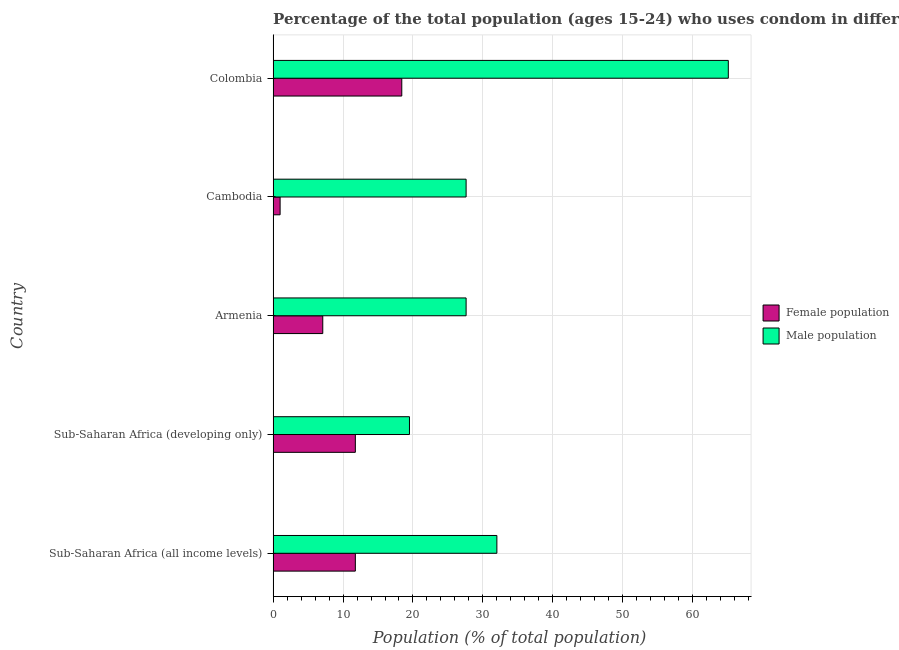How many bars are there on the 2nd tick from the bottom?
Your answer should be compact. 2. What is the label of the 5th group of bars from the top?
Ensure brevity in your answer.  Sub-Saharan Africa (all income levels). In how many cases, is the number of bars for a given country not equal to the number of legend labels?
Give a very brief answer. 0. What is the female population in Armenia?
Provide a succinct answer. 7.1. Across all countries, what is the maximum male population?
Your answer should be compact. 65.1. Across all countries, what is the minimum female population?
Provide a succinct answer. 1. In which country was the male population maximum?
Your answer should be very brief. Colombia. In which country was the male population minimum?
Your response must be concise. Sub-Saharan Africa (developing only). What is the total male population in the graph?
Offer a terse response. 171.8. What is the difference between the female population in Cambodia and that in Sub-Saharan Africa (all income levels)?
Offer a very short reply. -10.76. What is the difference between the female population in Colombia and the male population in Sub-Saharan Africa (developing only)?
Give a very brief answer. -1.1. What is the average male population per country?
Offer a terse response. 34.36. What is the difference between the female population and male population in Sub-Saharan Africa (all income levels)?
Make the answer very short. -20.24. What is the ratio of the female population in Armenia to that in Sub-Saharan Africa (developing only)?
Your answer should be compact. 0.6. Is the male population in Cambodia less than that in Colombia?
Provide a succinct answer. Yes. What is the difference between the highest and the second highest female population?
Give a very brief answer. 6.64. Is the sum of the male population in Cambodia and Sub-Saharan Africa (all income levels) greater than the maximum female population across all countries?
Provide a short and direct response. Yes. What does the 2nd bar from the top in Colombia represents?
Your answer should be compact. Female population. What does the 1st bar from the bottom in Colombia represents?
Give a very brief answer. Female population. Are all the bars in the graph horizontal?
Provide a succinct answer. Yes. How many countries are there in the graph?
Your answer should be compact. 5. Are the values on the major ticks of X-axis written in scientific E-notation?
Your response must be concise. No. Does the graph contain grids?
Provide a succinct answer. Yes. What is the title of the graph?
Make the answer very short. Percentage of the total population (ages 15-24) who uses condom in different countries. What is the label or title of the X-axis?
Offer a very short reply. Population (% of total population) . What is the Population (% of total population)  in Female population in Sub-Saharan Africa (all income levels)?
Provide a short and direct response. 11.76. What is the Population (% of total population)  of Male population in Sub-Saharan Africa (all income levels)?
Make the answer very short. 32. What is the Population (% of total population)  of Female population in Sub-Saharan Africa (developing only)?
Keep it short and to the point. 11.76. What is the Population (% of total population)  of Female population in Armenia?
Your answer should be compact. 7.1. What is the Population (% of total population)  in Male population in Armenia?
Your answer should be compact. 27.6. What is the Population (% of total population)  of Female population in Cambodia?
Provide a succinct answer. 1. What is the Population (% of total population)  in Male population in Cambodia?
Offer a very short reply. 27.6. What is the Population (% of total population)  in Female population in Colombia?
Offer a very short reply. 18.4. What is the Population (% of total population)  of Male population in Colombia?
Your answer should be compact. 65.1. Across all countries, what is the maximum Population (% of total population)  of Female population?
Ensure brevity in your answer.  18.4. Across all countries, what is the maximum Population (% of total population)  of Male population?
Provide a succinct answer. 65.1. What is the total Population (% of total population)  of Female population in the graph?
Offer a very short reply. 50.02. What is the total Population (% of total population)  in Male population in the graph?
Offer a terse response. 171.8. What is the difference between the Population (% of total population)  of Female population in Sub-Saharan Africa (all income levels) and that in Sub-Saharan Africa (developing only)?
Make the answer very short. 0. What is the difference between the Population (% of total population)  of Female population in Sub-Saharan Africa (all income levels) and that in Armenia?
Your response must be concise. 4.66. What is the difference between the Population (% of total population)  in Female population in Sub-Saharan Africa (all income levels) and that in Cambodia?
Offer a very short reply. 10.76. What is the difference between the Population (% of total population)  of Female population in Sub-Saharan Africa (all income levels) and that in Colombia?
Your answer should be compact. -6.64. What is the difference between the Population (% of total population)  in Male population in Sub-Saharan Africa (all income levels) and that in Colombia?
Provide a short and direct response. -33.1. What is the difference between the Population (% of total population)  of Female population in Sub-Saharan Africa (developing only) and that in Armenia?
Your response must be concise. 4.66. What is the difference between the Population (% of total population)  in Male population in Sub-Saharan Africa (developing only) and that in Armenia?
Provide a succinct answer. -8.1. What is the difference between the Population (% of total population)  of Female population in Sub-Saharan Africa (developing only) and that in Cambodia?
Keep it short and to the point. 10.76. What is the difference between the Population (% of total population)  of Male population in Sub-Saharan Africa (developing only) and that in Cambodia?
Ensure brevity in your answer.  -8.1. What is the difference between the Population (% of total population)  of Female population in Sub-Saharan Africa (developing only) and that in Colombia?
Keep it short and to the point. -6.64. What is the difference between the Population (% of total population)  of Male population in Sub-Saharan Africa (developing only) and that in Colombia?
Keep it short and to the point. -45.6. What is the difference between the Population (% of total population)  in Female population in Armenia and that in Cambodia?
Your answer should be compact. 6.1. What is the difference between the Population (% of total population)  of Female population in Armenia and that in Colombia?
Your response must be concise. -11.3. What is the difference between the Population (% of total population)  of Male population in Armenia and that in Colombia?
Make the answer very short. -37.5. What is the difference between the Population (% of total population)  of Female population in Cambodia and that in Colombia?
Your answer should be very brief. -17.4. What is the difference between the Population (% of total population)  in Male population in Cambodia and that in Colombia?
Offer a very short reply. -37.5. What is the difference between the Population (% of total population)  of Female population in Sub-Saharan Africa (all income levels) and the Population (% of total population)  of Male population in Sub-Saharan Africa (developing only)?
Offer a terse response. -7.74. What is the difference between the Population (% of total population)  in Female population in Sub-Saharan Africa (all income levels) and the Population (% of total population)  in Male population in Armenia?
Your answer should be compact. -15.84. What is the difference between the Population (% of total population)  of Female population in Sub-Saharan Africa (all income levels) and the Population (% of total population)  of Male population in Cambodia?
Your answer should be compact. -15.84. What is the difference between the Population (% of total population)  in Female population in Sub-Saharan Africa (all income levels) and the Population (% of total population)  in Male population in Colombia?
Your response must be concise. -53.34. What is the difference between the Population (% of total population)  in Female population in Sub-Saharan Africa (developing only) and the Population (% of total population)  in Male population in Armenia?
Give a very brief answer. -15.84. What is the difference between the Population (% of total population)  in Female population in Sub-Saharan Africa (developing only) and the Population (% of total population)  in Male population in Cambodia?
Your response must be concise. -15.84. What is the difference between the Population (% of total population)  in Female population in Sub-Saharan Africa (developing only) and the Population (% of total population)  in Male population in Colombia?
Offer a very short reply. -53.34. What is the difference between the Population (% of total population)  in Female population in Armenia and the Population (% of total population)  in Male population in Cambodia?
Give a very brief answer. -20.5. What is the difference between the Population (% of total population)  in Female population in Armenia and the Population (% of total population)  in Male population in Colombia?
Provide a succinct answer. -58. What is the difference between the Population (% of total population)  in Female population in Cambodia and the Population (% of total population)  in Male population in Colombia?
Make the answer very short. -64.1. What is the average Population (% of total population)  of Female population per country?
Offer a very short reply. 10. What is the average Population (% of total population)  of Male population per country?
Your answer should be very brief. 34.36. What is the difference between the Population (% of total population)  of Female population and Population (% of total population)  of Male population in Sub-Saharan Africa (all income levels)?
Your answer should be compact. -20.24. What is the difference between the Population (% of total population)  of Female population and Population (% of total population)  of Male population in Sub-Saharan Africa (developing only)?
Ensure brevity in your answer.  -7.74. What is the difference between the Population (% of total population)  in Female population and Population (% of total population)  in Male population in Armenia?
Offer a very short reply. -20.5. What is the difference between the Population (% of total population)  in Female population and Population (% of total population)  in Male population in Cambodia?
Provide a succinct answer. -26.6. What is the difference between the Population (% of total population)  of Female population and Population (% of total population)  of Male population in Colombia?
Give a very brief answer. -46.7. What is the ratio of the Population (% of total population)  of Male population in Sub-Saharan Africa (all income levels) to that in Sub-Saharan Africa (developing only)?
Your answer should be very brief. 1.64. What is the ratio of the Population (% of total population)  in Female population in Sub-Saharan Africa (all income levels) to that in Armenia?
Ensure brevity in your answer.  1.66. What is the ratio of the Population (% of total population)  in Male population in Sub-Saharan Africa (all income levels) to that in Armenia?
Make the answer very short. 1.16. What is the ratio of the Population (% of total population)  in Female population in Sub-Saharan Africa (all income levels) to that in Cambodia?
Provide a succinct answer. 11.76. What is the ratio of the Population (% of total population)  of Male population in Sub-Saharan Africa (all income levels) to that in Cambodia?
Provide a short and direct response. 1.16. What is the ratio of the Population (% of total population)  of Female population in Sub-Saharan Africa (all income levels) to that in Colombia?
Your answer should be compact. 0.64. What is the ratio of the Population (% of total population)  of Male population in Sub-Saharan Africa (all income levels) to that in Colombia?
Provide a short and direct response. 0.49. What is the ratio of the Population (% of total population)  of Female population in Sub-Saharan Africa (developing only) to that in Armenia?
Give a very brief answer. 1.66. What is the ratio of the Population (% of total population)  in Male population in Sub-Saharan Africa (developing only) to that in Armenia?
Make the answer very short. 0.71. What is the ratio of the Population (% of total population)  of Female population in Sub-Saharan Africa (developing only) to that in Cambodia?
Your answer should be very brief. 11.76. What is the ratio of the Population (% of total population)  of Male population in Sub-Saharan Africa (developing only) to that in Cambodia?
Give a very brief answer. 0.71. What is the ratio of the Population (% of total population)  of Female population in Sub-Saharan Africa (developing only) to that in Colombia?
Ensure brevity in your answer.  0.64. What is the ratio of the Population (% of total population)  of Male population in Sub-Saharan Africa (developing only) to that in Colombia?
Ensure brevity in your answer.  0.3. What is the ratio of the Population (% of total population)  of Female population in Armenia to that in Cambodia?
Make the answer very short. 7.1. What is the ratio of the Population (% of total population)  of Male population in Armenia to that in Cambodia?
Provide a succinct answer. 1. What is the ratio of the Population (% of total population)  in Female population in Armenia to that in Colombia?
Offer a terse response. 0.39. What is the ratio of the Population (% of total population)  in Male population in Armenia to that in Colombia?
Keep it short and to the point. 0.42. What is the ratio of the Population (% of total population)  in Female population in Cambodia to that in Colombia?
Ensure brevity in your answer.  0.05. What is the ratio of the Population (% of total population)  of Male population in Cambodia to that in Colombia?
Give a very brief answer. 0.42. What is the difference between the highest and the second highest Population (% of total population)  in Female population?
Offer a terse response. 6.64. What is the difference between the highest and the second highest Population (% of total population)  of Male population?
Offer a terse response. 33.1. What is the difference between the highest and the lowest Population (% of total population)  of Male population?
Offer a very short reply. 45.6. 